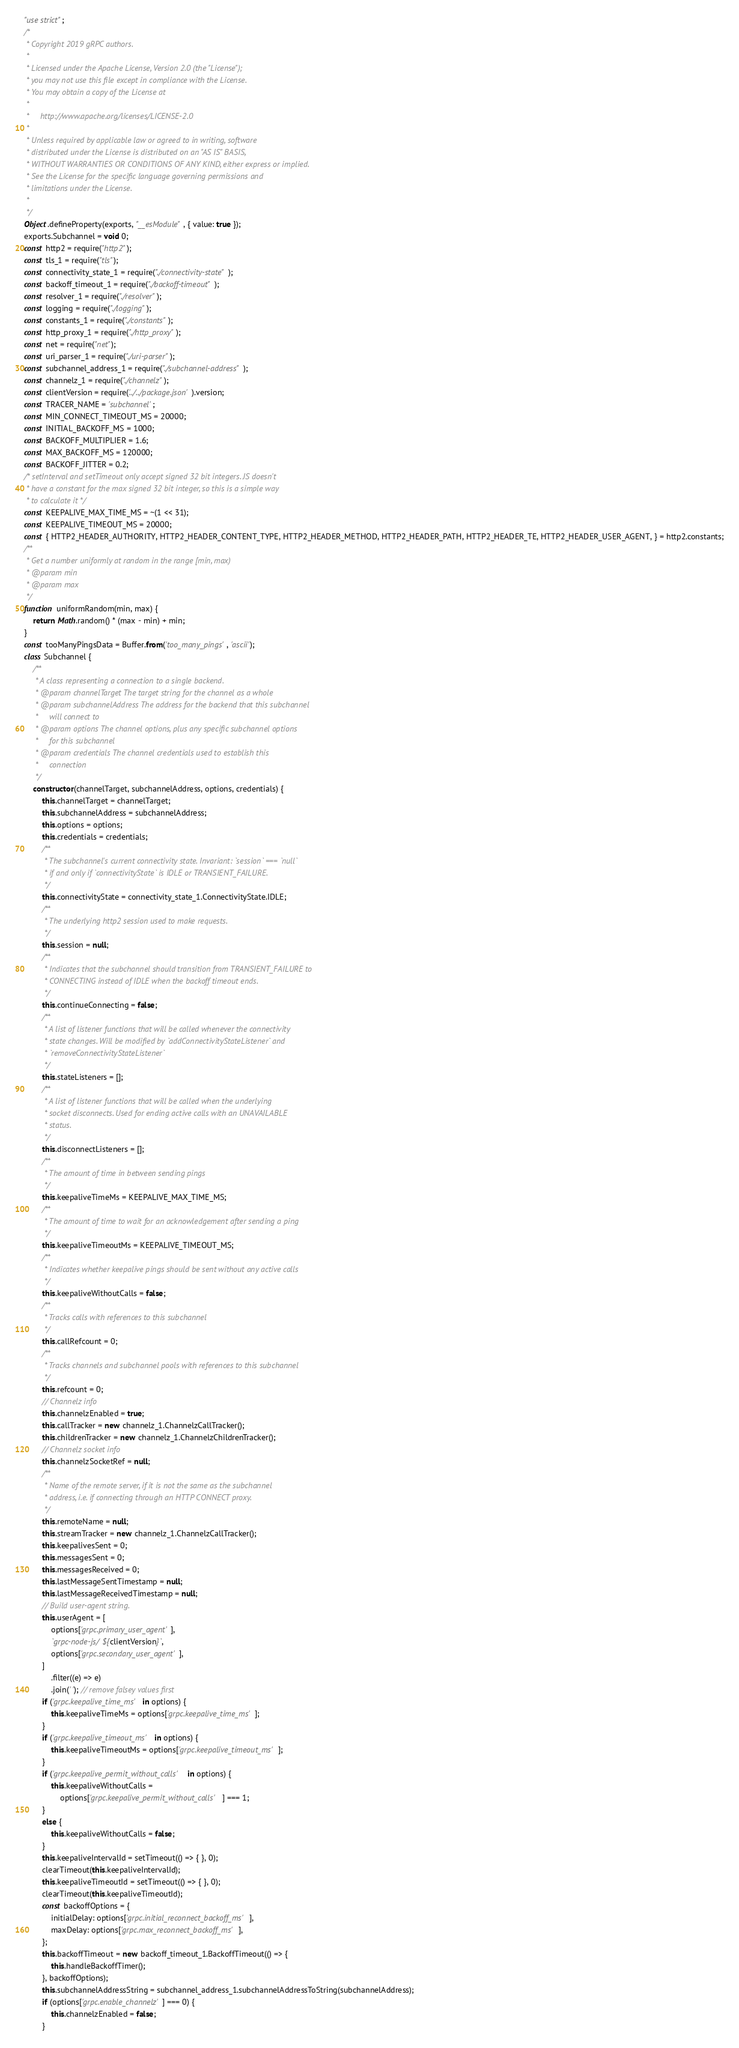<code> <loc_0><loc_0><loc_500><loc_500><_JavaScript_>"use strict";
/*
 * Copyright 2019 gRPC authors.
 *
 * Licensed under the Apache License, Version 2.0 (the "License");
 * you may not use this file except in compliance with the License.
 * You may obtain a copy of the License at
 *
 *     http://www.apache.org/licenses/LICENSE-2.0
 *
 * Unless required by applicable law or agreed to in writing, software
 * distributed under the License is distributed on an "AS IS" BASIS,
 * WITHOUT WARRANTIES OR CONDITIONS OF ANY KIND, either express or implied.
 * See the License for the specific language governing permissions and
 * limitations under the License.
 *
 */
Object.defineProperty(exports, "__esModule", { value: true });
exports.Subchannel = void 0;
const http2 = require("http2");
const tls_1 = require("tls");
const connectivity_state_1 = require("./connectivity-state");
const backoff_timeout_1 = require("./backoff-timeout");
const resolver_1 = require("./resolver");
const logging = require("./logging");
const constants_1 = require("./constants");
const http_proxy_1 = require("./http_proxy");
const net = require("net");
const uri_parser_1 = require("./uri-parser");
const subchannel_address_1 = require("./subchannel-address");
const channelz_1 = require("./channelz");
const clientVersion = require('../../package.json').version;
const TRACER_NAME = 'subchannel';
const MIN_CONNECT_TIMEOUT_MS = 20000;
const INITIAL_BACKOFF_MS = 1000;
const BACKOFF_MULTIPLIER = 1.6;
const MAX_BACKOFF_MS = 120000;
const BACKOFF_JITTER = 0.2;
/* setInterval and setTimeout only accept signed 32 bit integers. JS doesn't
 * have a constant for the max signed 32 bit integer, so this is a simple way
 * to calculate it */
const KEEPALIVE_MAX_TIME_MS = ~(1 << 31);
const KEEPALIVE_TIMEOUT_MS = 20000;
const { HTTP2_HEADER_AUTHORITY, HTTP2_HEADER_CONTENT_TYPE, HTTP2_HEADER_METHOD, HTTP2_HEADER_PATH, HTTP2_HEADER_TE, HTTP2_HEADER_USER_AGENT, } = http2.constants;
/**
 * Get a number uniformly at random in the range [min, max)
 * @param min
 * @param max
 */
function uniformRandom(min, max) {
    return Math.random() * (max - min) + min;
}
const tooManyPingsData = Buffer.from('too_many_pings', 'ascii');
class Subchannel {
    /**
     * A class representing a connection to a single backend.
     * @param channelTarget The target string for the channel as a whole
     * @param subchannelAddress The address for the backend that this subchannel
     *     will connect to
     * @param options The channel options, plus any specific subchannel options
     *     for this subchannel
     * @param credentials The channel credentials used to establish this
     *     connection
     */
    constructor(channelTarget, subchannelAddress, options, credentials) {
        this.channelTarget = channelTarget;
        this.subchannelAddress = subchannelAddress;
        this.options = options;
        this.credentials = credentials;
        /**
         * The subchannel's current connectivity state. Invariant: `session` === `null`
         * if and only if `connectivityState` is IDLE or TRANSIENT_FAILURE.
         */
        this.connectivityState = connectivity_state_1.ConnectivityState.IDLE;
        /**
         * The underlying http2 session used to make requests.
         */
        this.session = null;
        /**
         * Indicates that the subchannel should transition from TRANSIENT_FAILURE to
         * CONNECTING instead of IDLE when the backoff timeout ends.
         */
        this.continueConnecting = false;
        /**
         * A list of listener functions that will be called whenever the connectivity
         * state changes. Will be modified by `addConnectivityStateListener` and
         * `removeConnectivityStateListener`
         */
        this.stateListeners = [];
        /**
         * A list of listener functions that will be called when the underlying
         * socket disconnects. Used for ending active calls with an UNAVAILABLE
         * status.
         */
        this.disconnectListeners = [];
        /**
         * The amount of time in between sending pings
         */
        this.keepaliveTimeMs = KEEPALIVE_MAX_TIME_MS;
        /**
         * The amount of time to wait for an acknowledgement after sending a ping
         */
        this.keepaliveTimeoutMs = KEEPALIVE_TIMEOUT_MS;
        /**
         * Indicates whether keepalive pings should be sent without any active calls
         */
        this.keepaliveWithoutCalls = false;
        /**
         * Tracks calls with references to this subchannel
         */
        this.callRefcount = 0;
        /**
         * Tracks channels and subchannel pools with references to this subchannel
         */
        this.refcount = 0;
        // Channelz info
        this.channelzEnabled = true;
        this.callTracker = new channelz_1.ChannelzCallTracker();
        this.childrenTracker = new channelz_1.ChannelzChildrenTracker();
        // Channelz socket info
        this.channelzSocketRef = null;
        /**
         * Name of the remote server, if it is not the same as the subchannel
         * address, i.e. if connecting through an HTTP CONNECT proxy.
         */
        this.remoteName = null;
        this.streamTracker = new channelz_1.ChannelzCallTracker();
        this.keepalivesSent = 0;
        this.messagesSent = 0;
        this.messagesReceived = 0;
        this.lastMessageSentTimestamp = null;
        this.lastMessageReceivedTimestamp = null;
        // Build user-agent string.
        this.userAgent = [
            options['grpc.primary_user_agent'],
            `grpc-node-js/${clientVersion}`,
            options['grpc.secondary_user_agent'],
        ]
            .filter((e) => e)
            .join(' '); // remove falsey values first
        if ('grpc.keepalive_time_ms' in options) {
            this.keepaliveTimeMs = options['grpc.keepalive_time_ms'];
        }
        if ('grpc.keepalive_timeout_ms' in options) {
            this.keepaliveTimeoutMs = options['grpc.keepalive_timeout_ms'];
        }
        if ('grpc.keepalive_permit_without_calls' in options) {
            this.keepaliveWithoutCalls =
                options['grpc.keepalive_permit_without_calls'] === 1;
        }
        else {
            this.keepaliveWithoutCalls = false;
        }
        this.keepaliveIntervalId = setTimeout(() => { }, 0);
        clearTimeout(this.keepaliveIntervalId);
        this.keepaliveTimeoutId = setTimeout(() => { }, 0);
        clearTimeout(this.keepaliveTimeoutId);
        const backoffOptions = {
            initialDelay: options['grpc.initial_reconnect_backoff_ms'],
            maxDelay: options['grpc.max_reconnect_backoff_ms'],
        };
        this.backoffTimeout = new backoff_timeout_1.BackoffTimeout(() => {
            this.handleBackoffTimer();
        }, backoffOptions);
        this.subchannelAddressString = subchannel_address_1.subchannelAddressToString(subchannelAddress);
        if (options['grpc.enable_channelz'] === 0) {
            this.channelzEnabled = false;
        }</code> 